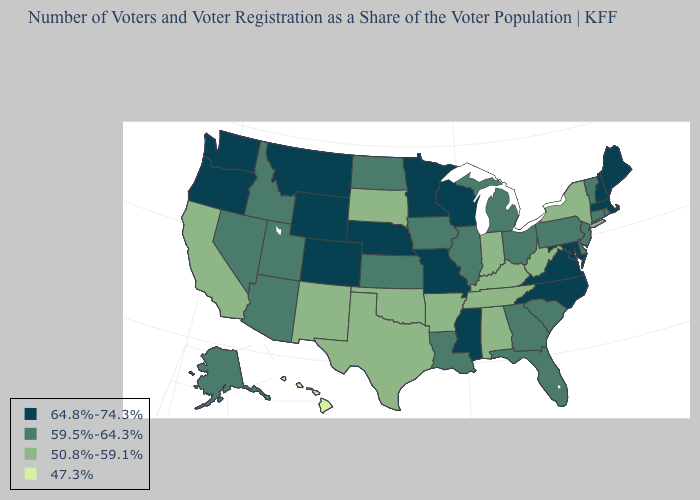What is the highest value in the MidWest ?
Quick response, please. 64.8%-74.3%. Among the states that border Oregon , does Washington have the highest value?
Give a very brief answer. Yes. Name the states that have a value in the range 47.3%?
Answer briefly. Hawaii. Does Virginia have the lowest value in the South?
Quick response, please. No. Among the states that border Montana , does Idaho have the lowest value?
Give a very brief answer. No. Name the states that have a value in the range 59.5%-64.3%?
Concise answer only. Alaska, Arizona, Connecticut, Delaware, Florida, Georgia, Idaho, Illinois, Iowa, Kansas, Louisiana, Michigan, Nevada, New Jersey, North Dakota, Ohio, Pennsylvania, Rhode Island, South Carolina, Utah, Vermont. Does New Jersey have the same value as Kansas?
Keep it brief. Yes. Name the states that have a value in the range 50.8%-59.1%?
Write a very short answer. Alabama, Arkansas, California, Indiana, Kentucky, New Mexico, New York, Oklahoma, South Dakota, Tennessee, Texas, West Virginia. What is the value of Alaska?
Concise answer only. 59.5%-64.3%. Is the legend a continuous bar?
Keep it brief. No. Name the states that have a value in the range 47.3%?
Write a very short answer. Hawaii. Does Michigan have the lowest value in the MidWest?
Concise answer only. No. What is the value of Mississippi?
Concise answer only. 64.8%-74.3%. Among the states that border Missouri , which have the highest value?
Be succinct. Nebraska. What is the highest value in states that border Idaho?
Quick response, please. 64.8%-74.3%. 